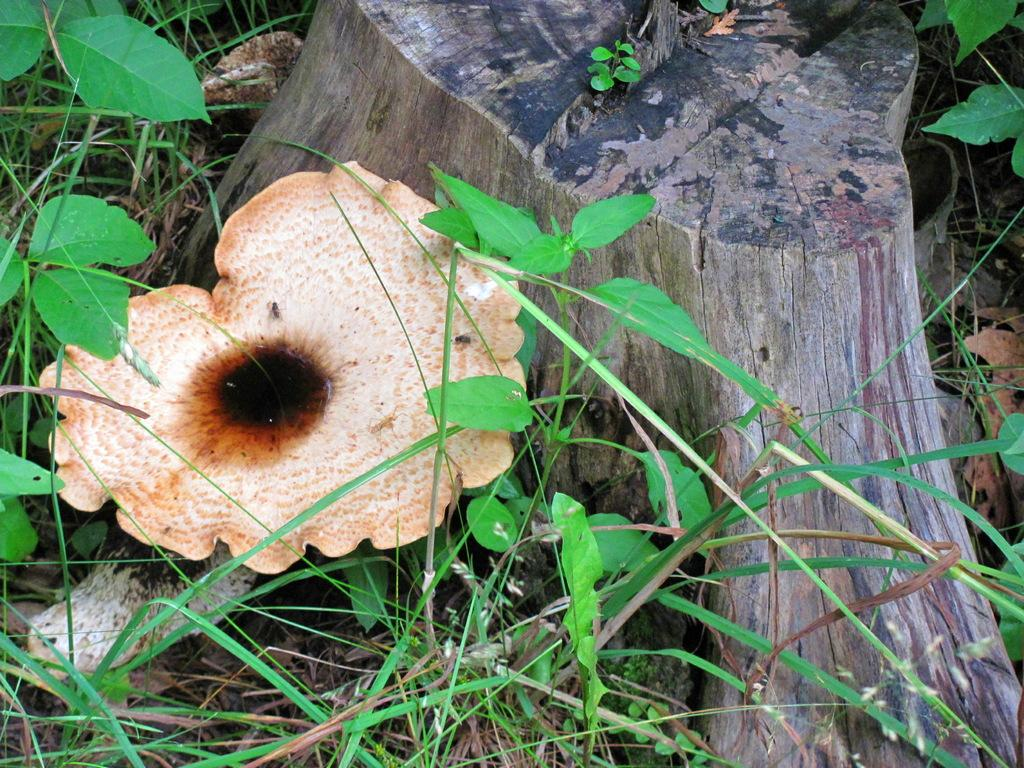What type of vegetation is present in the image? There is grass in the image. Are there any other plants or objects visible in the image? Yes, there is a mushroom in the image. What color is the chin of the person in the image? There is no person present in the image, so it is not possible to determine the color of their chin. 